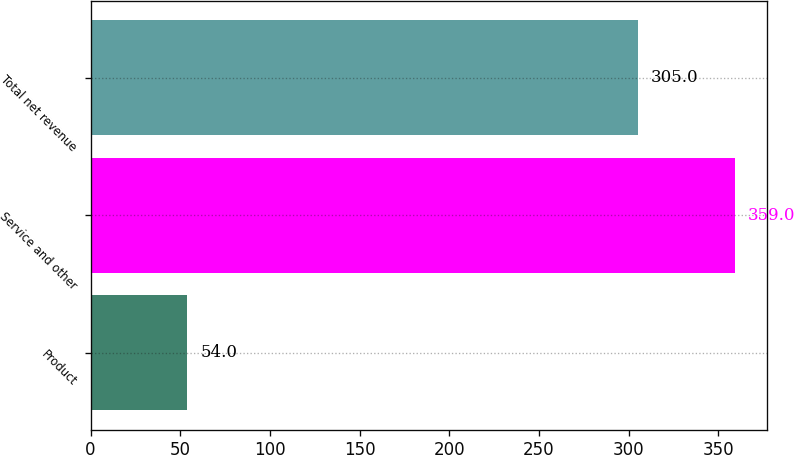Convert chart to OTSL. <chart><loc_0><loc_0><loc_500><loc_500><bar_chart><fcel>Product<fcel>Service and other<fcel>Total net revenue<nl><fcel>54<fcel>359<fcel>305<nl></chart> 